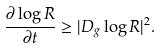Convert formula to latex. <formula><loc_0><loc_0><loc_500><loc_500>\frac { \partial \log R } { \partial t } \geq | D _ { g } \log R | ^ { 2 } .</formula> 